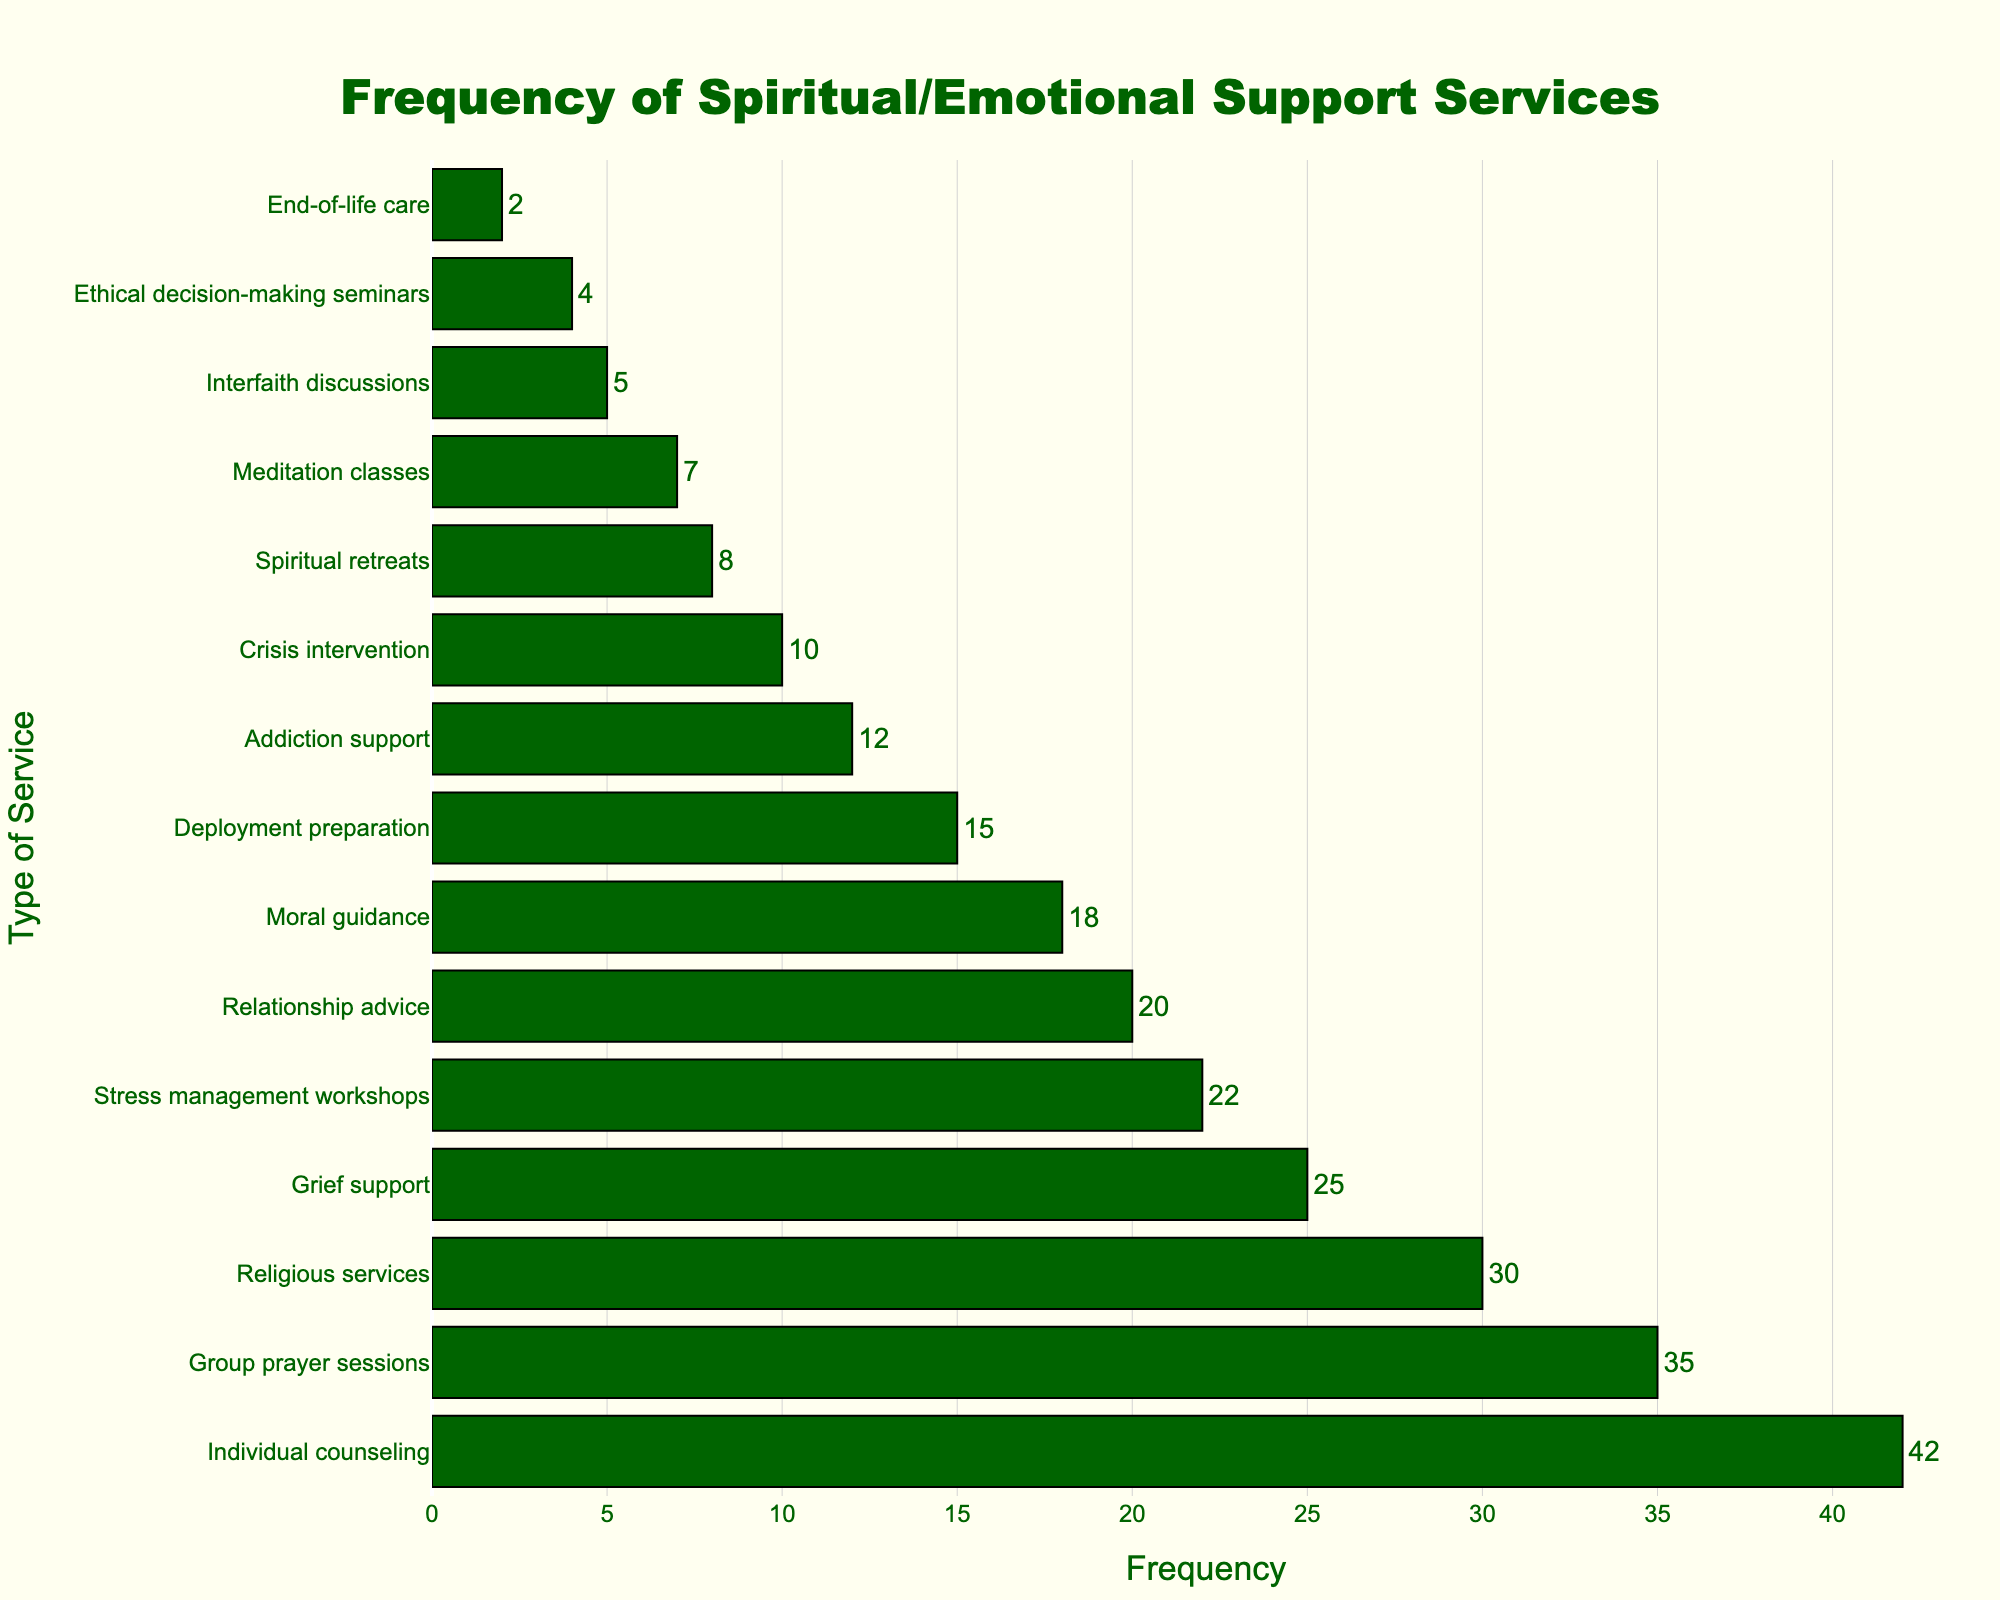What's the most requested type of spiritual/emotional support service? The highest bar in the chart represents the most requested type of spiritual/emotional support service. The "Individual counseling" bar is the longest with a frequency of 42.
Answer: Individual counseling Which service has a frequency of 22? Find the bar with a frequency label of 22. The "Stress management workshops" bar matches this frequency.
Answer: Stress management workshops How many more requests are there for "Individual counseling" compared to "Group prayer sessions"? Subtract the frequency of "Group prayer sessions" (35) from that of "Individual counseling" (42). The difference is 42 - 35 = 7.
Answer: 7 Are requests for "Relationship advice" more or less than for "Deployment preparation"? Compare the lengths of the bars for "Relationship advice" and "Deployment preparation". "Relationship advice" has a frequency of 20 and "Deployment preparation" has a frequency of 15. 20 is greater than 15, so there are more requests for "Relationship advice".
Answer: More What's the total frequency of "Crisis intervention" and "Spiritual retreats"? Add the frequencies of "Crisis intervention" (10) and "Spiritual retreats" (8). The sum is 10 + 8 = 18.
Answer: 18 Which type of service has the lowest frequency and what's that frequency? Find the shortest bar on the chart which represents the lowest frequency. "End-of-life care" has the shortest bar with a frequency of 2.
Answer: End-of-life care, 2 How does the frequency of "Group prayer sessions" compare to "Meditation classes"? Compare the frequencies: "Group prayer sessions" has 35 and "Meditation classes" has 7. 35 is greater than 7.
Answer: Greater than What's the average frequency of "Religious services", "Grief support", and "Stress management workshops"? Calculate the average by adding the frequencies of these three services and dividing by 3. (30 + 25 + 22) / 3 = 77 / 3 ≈ 25.67.
Answer: Approximately 25.67 What is the combined frequency of all services with a frequency above 20? Identify and sum the frequencies of all services with frequencies above 20: "Individual counseling" (42), "Group prayer sessions" (35), "Religious services" (30), "Grief support" (25), and "Stress management workshops" (22). The total is 42 + 35 + 30 + 25 + 22 = 154.
Answer: 154 